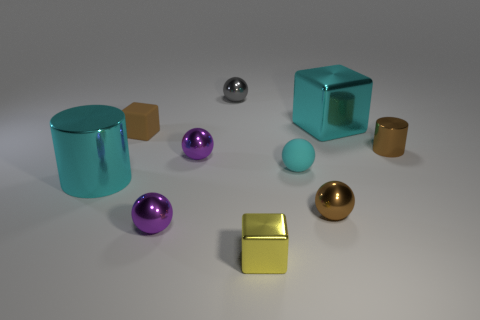Subtract all tiny cyan spheres. How many spheres are left? 4 Subtract all cyan spheres. How many spheres are left? 4 Subtract all green balls. Subtract all purple cubes. How many balls are left? 5 Subtract all cylinders. How many objects are left? 8 Add 6 purple metallic spheres. How many purple metallic spheres exist? 8 Subtract 0 yellow cylinders. How many objects are left? 10 Subtract all tiny cyan metal things. Subtract all tiny matte spheres. How many objects are left? 9 Add 1 small cyan matte spheres. How many small cyan matte spheres are left? 2 